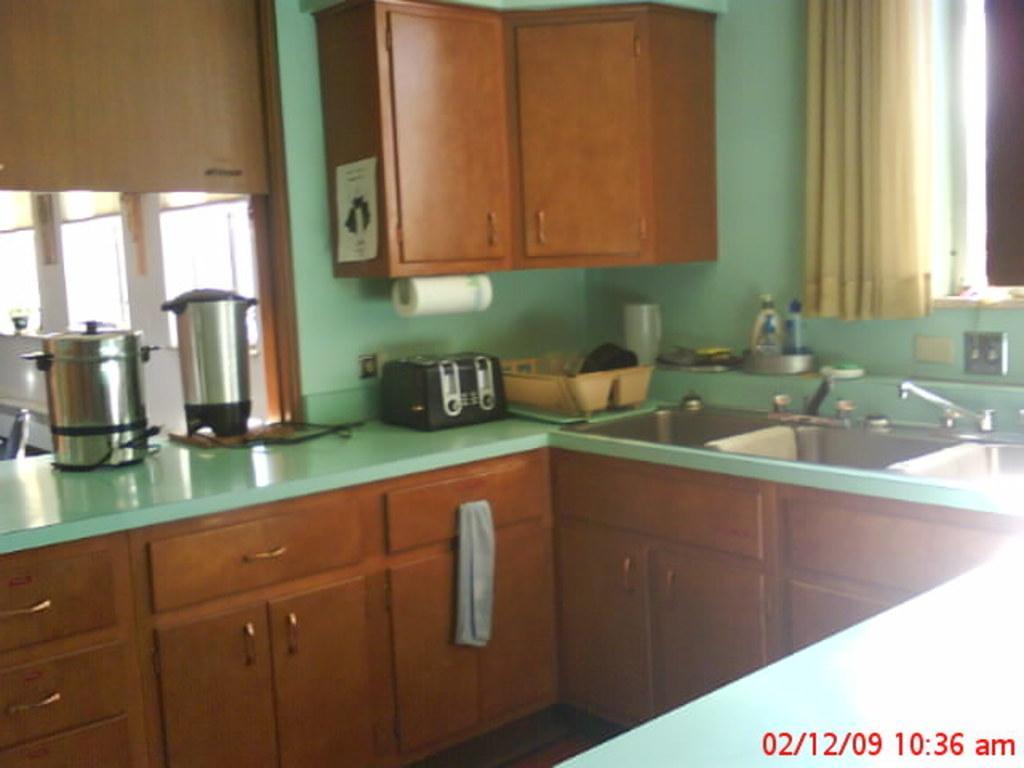Please provide a concise description of this image. This is a kitchen. There is a table with drawers. On the table there are kitchen equipment, wash basins, taps, basket, bottles and many other things. Also there is a curtain. On the wall there is a cupboard. Near to that there is a tissue roll. In the right bottom corner there is a watermark. 